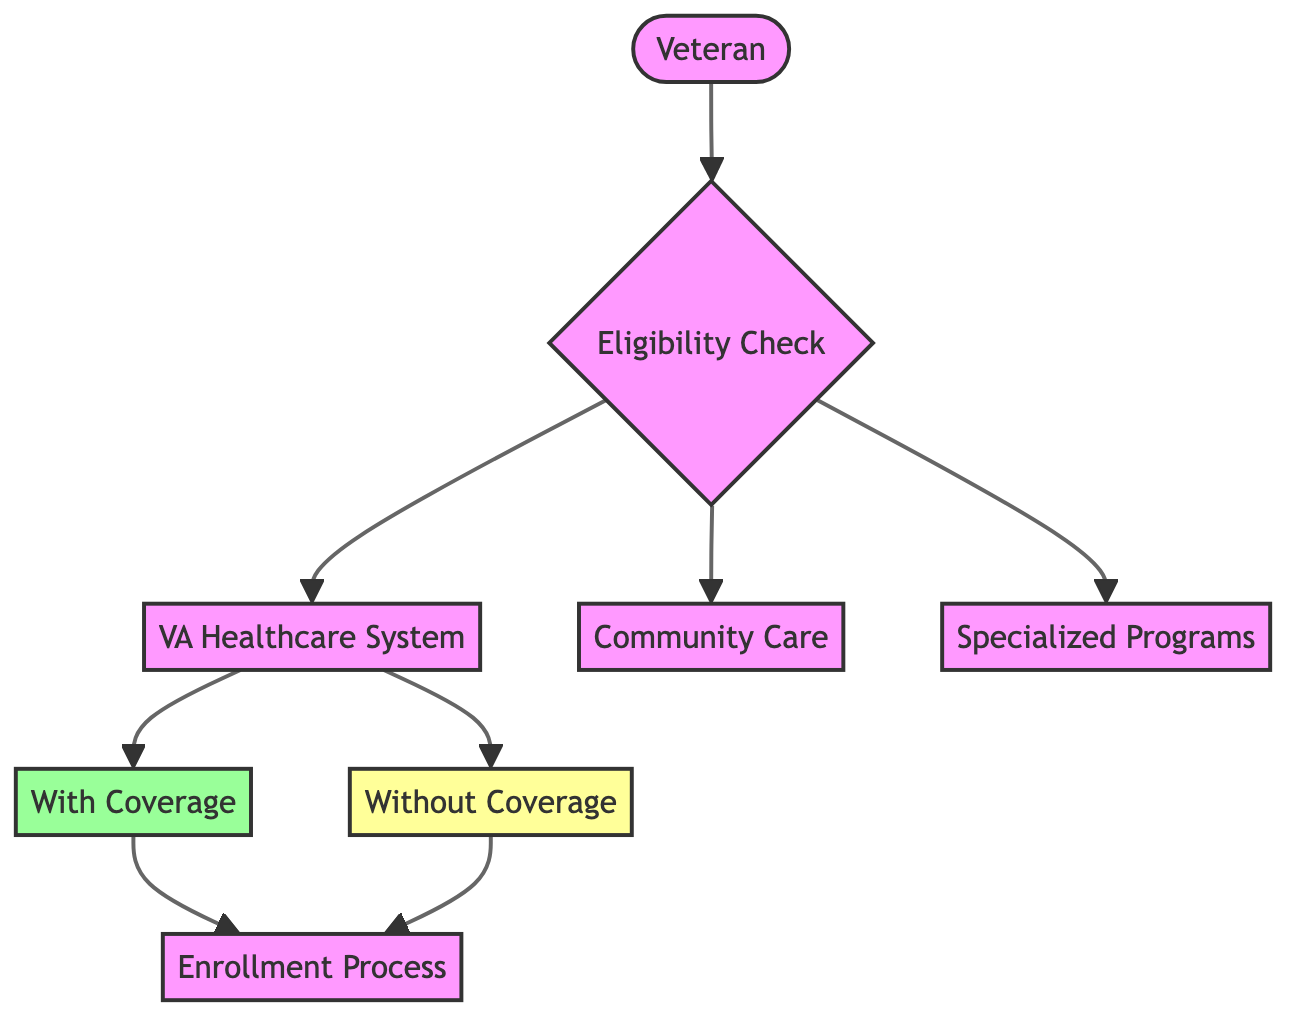What is the starting point in the flowchart? The starting point is the "Veteran" node. This is where the process begins as it represents the individual who has served in the military.
Answer: Veteran How many main options are available after the eligibility check? After the "Eligibility Check," there are three main options: "VA Healthcare System," "Community Care," and "Specialized Programs." This is seen in the outgoing connections from the "Eligibility Check" node.
Answer: 3 Which node indicates that a veteran qualifies for healthcare benefits? The node that indicates qualification for healthcare benefits is "With Coverage." This is a direct output of the "VA Healthcare System" node, showing the result for eligible veterans.
Answer: With Coverage What happens if a veteran does not qualify for full VA healthcare benefits? If a veteran does not qualify, they will be directed to "Without Coverage," which signifies the absence of full healthcare benefits as indicated in the diagram.
Answer: Without Coverage What is the final step in the healthcare services flowchart? The final step in the flowchart is the "Enrollment Process," which all paths lead to after determining eligibility and coverage status. It signifies how to apply for VA health services.
Answer: Enrollment Process How many nodes represent different types of healthcare services? There are three nodes that represent different types of healthcare services: "VA Healthcare System," "Community Care," and "Specialized Programs." These options stem from the eligibility check.
Answer: 3 Which relationship shows a veteran's transition from without coverage to the enrollment process? The relationship that shows this transition is the directed edge from "Without Coverage" to "Enrollment," indicating that even those without full coverage can proceed to the enrollment stage.
Answer: Without Coverage to Enrollment What are the two paths available after the eligibility check for healthcare services? The two paths available after the eligibility check lead to "VA Healthcare System" and "Community Care." Both options are critical for veterans depending on their eligibility status.
Answer: VA Healthcare System and Community Care 